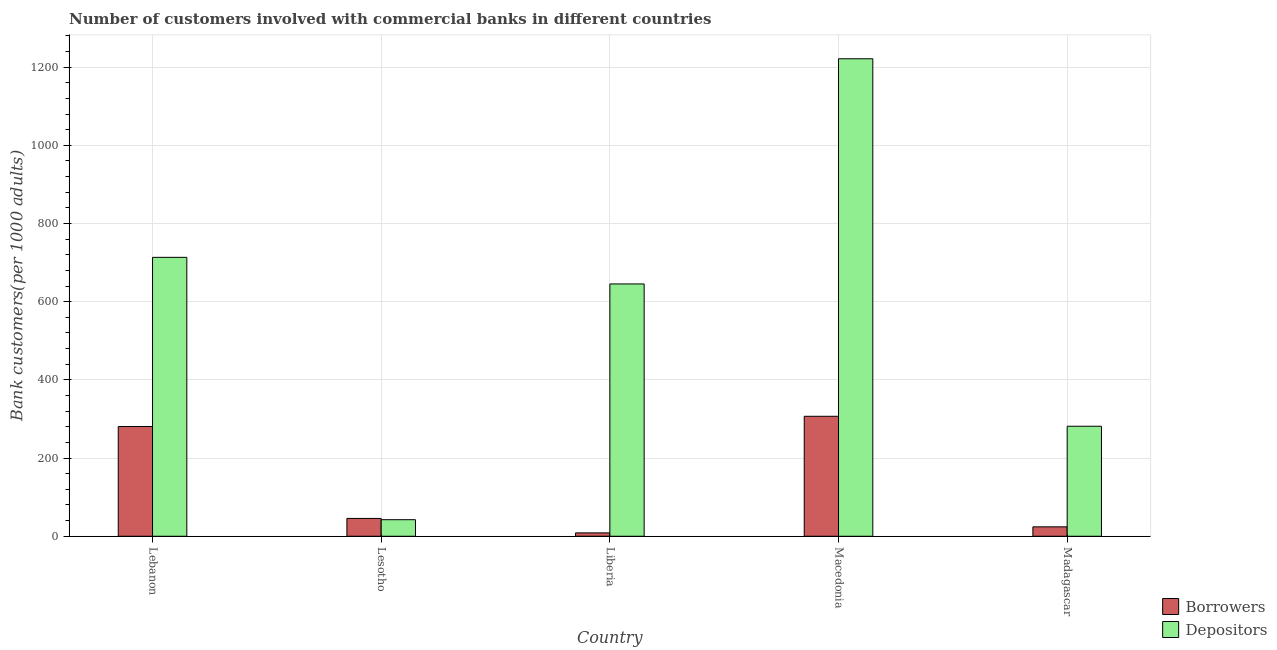How many different coloured bars are there?
Keep it short and to the point. 2. Are the number of bars per tick equal to the number of legend labels?
Provide a short and direct response. Yes. How many bars are there on the 1st tick from the right?
Give a very brief answer. 2. What is the label of the 2nd group of bars from the left?
Provide a short and direct response. Lesotho. In how many cases, is the number of bars for a given country not equal to the number of legend labels?
Make the answer very short. 0. What is the number of depositors in Liberia?
Your response must be concise. 645.37. Across all countries, what is the maximum number of borrowers?
Your answer should be very brief. 306.84. Across all countries, what is the minimum number of depositors?
Your response must be concise. 42.35. In which country was the number of depositors maximum?
Ensure brevity in your answer.  Macedonia. In which country was the number of depositors minimum?
Your answer should be very brief. Lesotho. What is the total number of depositors in the graph?
Your answer should be very brief. 2903.91. What is the difference between the number of depositors in Macedonia and that in Madagascar?
Your answer should be very brief. 940.02. What is the difference between the number of borrowers in Lebanon and the number of depositors in Liberia?
Give a very brief answer. -364.7. What is the average number of borrowers per country?
Give a very brief answer. 133.15. What is the difference between the number of depositors and number of borrowers in Lebanon?
Your answer should be very brief. 432.74. What is the ratio of the number of borrowers in Liberia to that in Macedonia?
Offer a terse response. 0.03. What is the difference between the highest and the second highest number of borrowers?
Ensure brevity in your answer.  26.17. What is the difference between the highest and the lowest number of borrowers?
Make the answer very short. 298.23. What does the 2nd bar from the left in Lebanon represents?
Provide a succinct answer. Depositors. What does the 1st bar from the right in Madagascar represents?
Keep it short and to the point. Depositors. How many bars are there?
Your response must be concise. 10. What is the difference between two consecutive major ticks on the Y-axis?
Offer a very short reply. 200. Are the values on the major ticks of Y-axis written in scientific E-notation?
Ensure brevity in your answer.  No. Does the graph contain any zero values?
Offer a terse response. No. Does the graph contain grids?
Your response must be concise. Yes. Where does the legend appear in the graph?
Your answer should be compact. Bottom right. How are the legend labels stacked?
Your answer should be compact. Vertical. What is the title of the graph?
Keep it short and to the point. Number of customers involved with commercial banks in different countries. What is the label or title of the X-axis?
Your answer should be very brief. Country. What is the label or title of the Y-axis?
Make the answer very short. Bank customers(per 1000 adults). What is the Bank customers(per 1000 adults) in Borrowers in Lebanon?
Offer a very short reply. 280.67. What is the Bank customers(per 1000 adults) in Depositors in Lebanon?
Your response must be concise. 713.41. What is the Bank customers(per 1000 adults) of Borrowers in Lesotho?
Give a very brief answer. 45.58. What is the Bank customers(per 1000 adults) in Depositors in Lesotho?
Your answer should be very brief. 42.35. What is the Bank customers(per 1000 adults) in Borrowers in Liberia?
Offer a very short reply. 8.61. What is the Bank customers(per 1000 adults) in Depositors in Liberia?
Make the answer very short. 645.37. What is the Bank customers(per 1000 adults) in Borrowers in Macedonia?
Provide a succinct answer. 306.84. What is the Bank customers(per 1000 adults) of Depositors in Macedonia?
Keep it short and to the point. 1221.4. What is the Bank customers(per 1000 adults) of Borrowers in Madagascar?
Your response must be concise. 24.07. What is the Bank customers(per 1000 adults) of Depositors in Madagascar?
Your answer should be very brief. 281.38. Across all countries, what is the maximum Bank customers(per 1000 adults) of Borrowers?
Your answer should be very brief. 306.84. Across all countries, what is the maximum Bank customers(per 1000 adults) in Depositors?
Your response must be concise. 1221.4. Across all countries, what is the minimum Bank customers(per 1000 adults) of Borrowers?
Offer a very short reply. 8.61. Across all countries, what is the minimum Bank customers(per 1000 adults) in Depositors?
Provide a short and direct response. 42.35. What is the total Bank customers(per 1000 adults) of Borrowers in the graph?
Provide a short and direct response. 665.77. What is the total Bank customers(per 1000 adults) in Depositors in the graph?
Ensure brevity in your answer.  2903.91. What is the difference between the Bank customers(per 1000 adults) of Borrowers in Lebanon and that in Lesotho?
Your answer should be compact. 235.08. What is the difference between the Bank customers(per 1000 adults) in Depositors in Lebanon and that in Lesotho?
Keep it short and to the point. 671.06. What is the difference between the Bank customers(per 1000 adults) in Borrowers in Lebanon and that in Liberia?
Keep it short and to the point. 272.06. What is the difference between the Bank customers(per 1000 adults) in Depositors in Lebanon and that in Liberia?
Your answer should be very brief. 68.05. What is the difference between the Bank customers(per 1000 adults) in Borrowers in Lebanon and that in Macedonia?
Keep it short and to the point. -26.17. What is the difference between the Bank customers(per 1000 adults) in Depositors in Lebanon and that in Macedonia?
Make the answer very short. -507.99. What is the difference between the Bank customers(per 1000 adults) of Borrowers in Lebanon and that in Madagascar?
Ensure brevity in your answer.  256.6. What is the difference between the Bank customers(per 1000 adults) of Depositors in Lebanon and that in Madagascar?
Offer a terse response. 432.03. What is the difference between the Bank customers(per 1000 adults) of Borrowers in Lesotho and that in Liberia?
Ensure brevity in your answer.  36.98. What is the difference between the Bank customers(per 1000 adults) of Depositors in Lesotho and that in Liberia?
Give a very brief answer. -603.01. What is the difference between the Bank customers(per 1000 adults) in Borrowers in Lesotho and that in Macedonia?
Offer a terse response. -261.25. What is the difference between the Bank customers(per 1000 adults) in Depositors in Lesotho and that in Macedonia?
Your answer should be very brief. -1179.05. What is the difference between the Bank customers(per 1000 adults) in Borrowers in Lesotho and that in Madagascar?
Provide a succinct answer. 21.52. What is the difference between the Bank customers(per 1000 adults) in Depositors in Lesotho and that in Madagascar?
Offer a very short reply. -239.03. What is the difference between the Bank customers(per 1000 adults) of Borrowers in Liberia and that in Macedonia?
Keep it short and to the point. -298.23. What is the difference between the Bank customers(per 1000 adults) in Depositors in Liberia and that in Macedonia?
Your answer should be compact. -576.04. What is the difference between the Bank customers(per 1000 adults) in Borrowers in Liberia and that in Madagascar?
Keep it short and to the point. -15.46. What is the difference between the Bank customers(per 1000 adults) of Depositors in Liberia and that in Madagascar?
Offer a very short reply. 363.99. What is the difference between the Bank customers(per 1000 adults) in Borrowers in Macedonia and that in Madagascar?
Provide a succinct answer. 282.77. What is the difference between the Bank customers(per 1000 adults) of Depositors in Macedonia and that in Madagascar?
Keep it short and to the point. 940.02. What is the difference between the Bank customers(per 1000 adults) in Borrowers in Lebanon and the Bank customers(per 1000 adults) in Depositors in Lesotho?
Offer a terse response. 238.31. What is the difference between the Bank customers(per 1000 adults) of Borrowers in Lebanon and the Bank customers(per 1000 adults) of Depositors in Liberia?
Offer a terse response. -364.7. What is the difference between the Bank customers(per 1000 adults) in Borrowers in Lebanon and the Bank customers(per 1000 adults) in Depositors in Macedonia?
Keep it short and to the point. -940.74. What is the difference between the Bank customers(per 1000 adults) in Borrowers in Lebanon and the Bank customers(per 1000 adults) in Depositors in Madagascar?
Ensure brevity in your answer.  -0.71. What is the difference between the Bank customers(per 1000 adults) in Borrowers in Lesotho and the Bank customers(per 1000 adults) in Depositors in Liberia?
Offer a terse response. -599.78. What is the difference between the Bank customers(per 1000 adults) of Borrowers in Lesotho and the Bank customers(per 1000 adults) of Depositors in Macedonia?
Provide a succinct answer. -1175.82. What is the difference between the Bank customers(per 1000 adults) of Borrowers in Lesotho and the Bank customers(per 1000 adults) of Depositors in Madagascar?
Your response must be concise. -235.8. What is the difference between the Bank customers(per 1000 adults) in Borrowers in Liberia and the Bank customers(per 1000 adults) in Depositors in Macedonia?
Keep it short and to the point. -1212.79. What is the difference between the Bank customers(per 1000 adults) in Borrowers in Liberia and the Bank customers(per 1000 adults) in Depositors in Madagascar?
Give a very brief answer. -272.77. What is the difference between the Bank customers(per 1000 adults) of Borrowers in Macedonia and the Bank customers(per 1000 adults) of Depositors in Madagascar?
Provide a succinct answer. 25.46. What is the average Bank customers(per 1000 adults) in Borrowers per country?
Make the answer very short. 133.15. What is the average Bank customers(per 1000 adults) of Depositors per country?
Keep it short and to the point. 580.78. What is the difference between the Bank customers(per 1000 adults) of Borrowers and Bank customers(per 1000 adults) of Depositors in Lebanon?
Give a very brief answer. -432.74. What is the difference between the Bank customers(per 1000 adults) of Borrowers and Bank customers(per 1000 adults) of Depositors in Lesotho?
Keep it short and to the point. 3.23. What is the difference between the Bank customers(per 1000 adults) of Borrowers and Bank customers(per 1000 adults) of Depositors in Liberia?
Offer a very short reply. -636.76. What is the difference between the Bank customers(per 1000 adults) of Borrowers and Bank customers(per 1000 adults) of Depositors in Macedonia?
Make the answer very short. -914.56. What is the difference between the Bank customers(per 1000 adults) of Borrowers and Bank customers(per 1000 adults) of Depositors in Madagascar?
Your answer should be very brief. -257.31. What is the ratio of the Bank customers(per 1000 adults) of Borrowers in Lebanon to that in Lesotho?
Your response must be concise. 6.16. What is the ratio of the Bank customers(per 1000 adults) of Depositors in Lebanon to that in Lesotho?
Ensure brevity in your answer.  16.84. What is the ratio of the Bank customers(per 1000 adults) of Borrowers in Lebanon to that in Liberia?
Make the answer very short. 32.6. What is the ratio of the Bank customers(per 1000 adults) in Depositors in Lebanon to that in Liberia?
Provide a short and direct response. 1.11. What is the ratio of the Bank customers(per 1000 adults) in Borrowers in Lebanon to that in Macedonia?
Provide a short and direct response. 0.91. What is the ratio of the Bank customers(per 1000 adults) in Depositors in Lebanon to that in Macedonia?
Provide a short and direct response. 0.58. What is the ratio of the Bank customers(per 1000 adults) of Borrowers in Lebanon to that in Madagascar?
Your answer should be compact. 11.66. What is the ratio of the Bank customers(per 1000 adults) in Depositors in Lebanon to that in Madagascar?
Your answer should be compact. 2.54. What is the ratio of the Bank customers(per 1000 adults) of Borrowers in Lesotho to that in Liberia?
Your response must be concise. 5.29. What is the ratio of the Bank customers(per 1000 adults) of Depositors in Lesotho to that in Liberia?
Provide a short and direct response. 0.07. What is the ratio of the Bank customers(per 1000 adults) of Borrowers in Lesotho to that in Macedonia?
Offer a very short reply. 0.15. What is the ratio of the Bank customers(per 1000 adults) of Depositors in Lesotho to that in Macedonia?
Make the answer very short. 0.03. What is the ratio of the Bank customers(per 1000 adults) in Borrowers in Lesotho to that in Madagascar?
Ensure brevity in your answer.  1.89. What is the ratio of the Bank customers(per 1000 adults) of Depositors in Lesotho to that in Madagascar?
Keep it short and to the point. 0.15. What is the ratio of the Bank customers(per 1000 adults) in Borrowers in Liberia to that in Macedonia?
Your response must be concise. 0.03. What is the ratio of the Bank customers(per 1000 adults) of Depositors in Liberia to that in Macedonia?
Your response must be concise. 0.53. What is the ratio of the Bank customers(per 1000 adults) in Borrowers in Liberia to that in Madagascar?
Your response must be concise. 0.36. What is the ratio of the Bank customers(per 1000 adults) of Depositors in Liberia to that in Madagascar?
Your response must be concise. 2.29. What is the ratio of the Bank customers(per 1000 adults) in Borrowers in Macedonia to that in Madagascar?
Your answer should be very brief. 12.75. What is the ratio of the Bank customers(per 1000 adults) of Depositors in Macedonia to that in Madagascar?
Make the answer very short. 4.34. What is the difference between the highest and the second highest Bank customers(per 1000 adults) in Borrowers?
Offer a terse response. 26.17. What is the difference between the highest and the second highest Bank customers(per 1000 adults) of Depositors?
Keep it short and to the point. 507.99. What is the difference between the highest and the lowest Bank customers(per 1000 adults) in Borrowers?
Your response must be concise. 298.23. What is the difference between the highest and the lowest Bank customers(per 1000 adults) of Depositors?
Keep it short and to the point. 1179.05. 